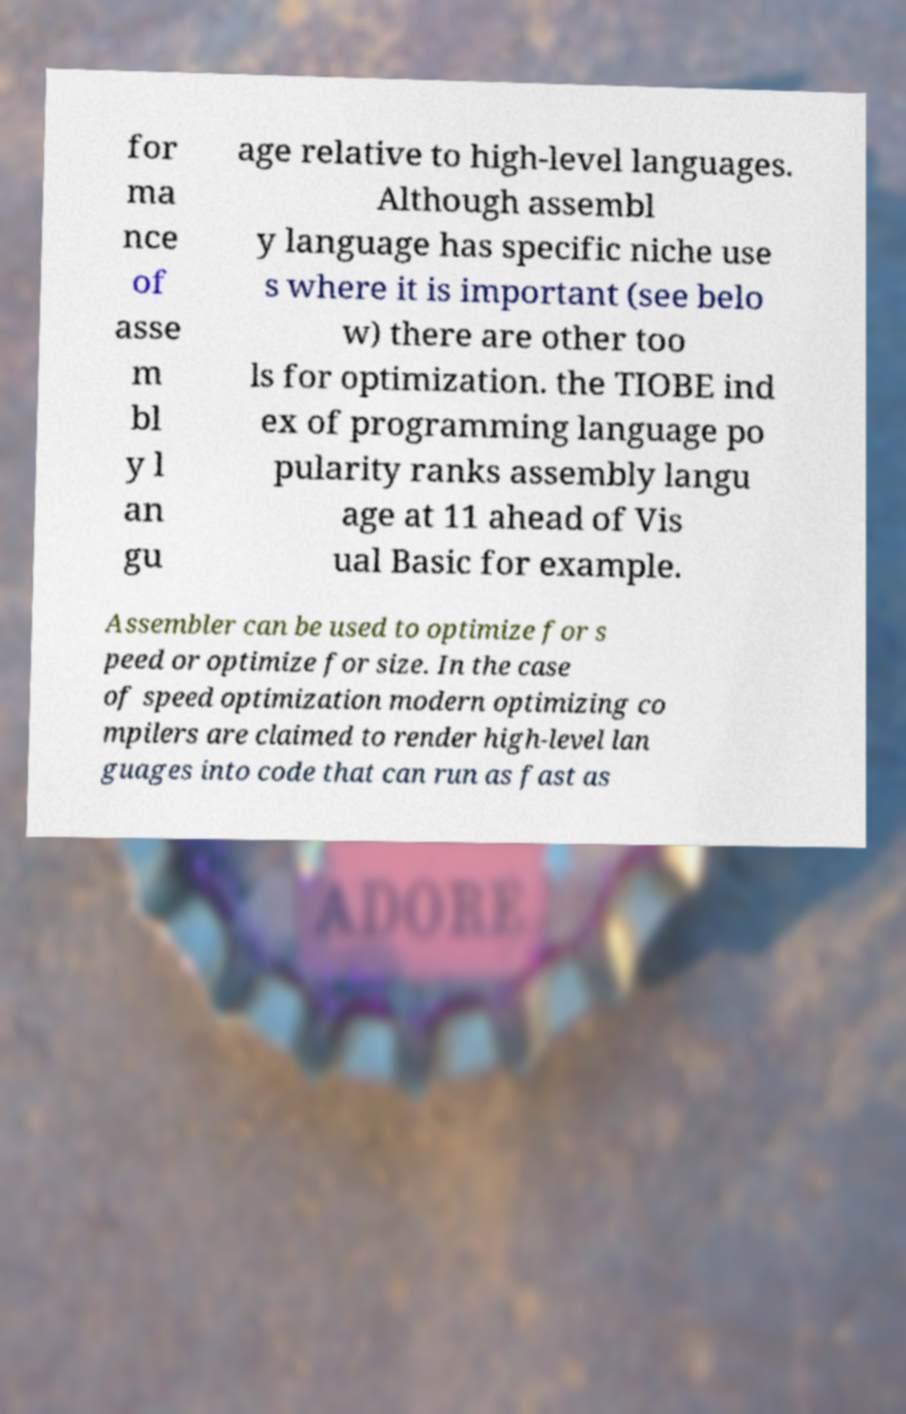There's text embedded in this image that I need extracted. Can you transcribe it verbatim? for ma nce of asse m bl y l an gu age relative to high-level languages. Although assembl y language has specific niche use s where it is important (see belo w) there are other too ls for optimization. the TIOBE ind ex of programming language po pularity ranks assembly langu age at 11 ahead of Vis ual Basic for example. Assembler can be used to optimize for s peed or optimize for size. In the case of speed optimization modern optimizing co mpilers are claimed to render high-level lan guages into code that can run as fast as 